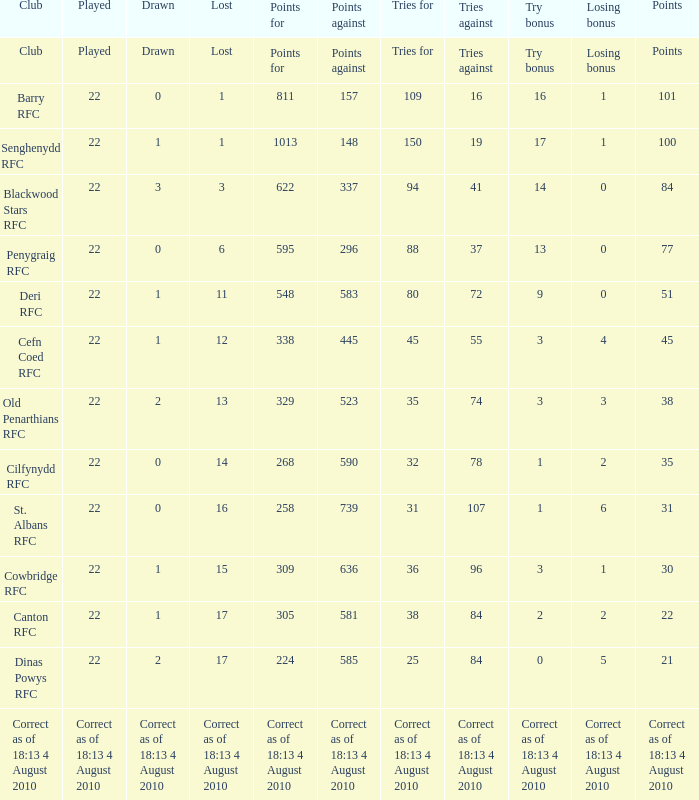What is the club's name when the played number is 22, and the try bonus is 0? Dinas Powys RFC. 